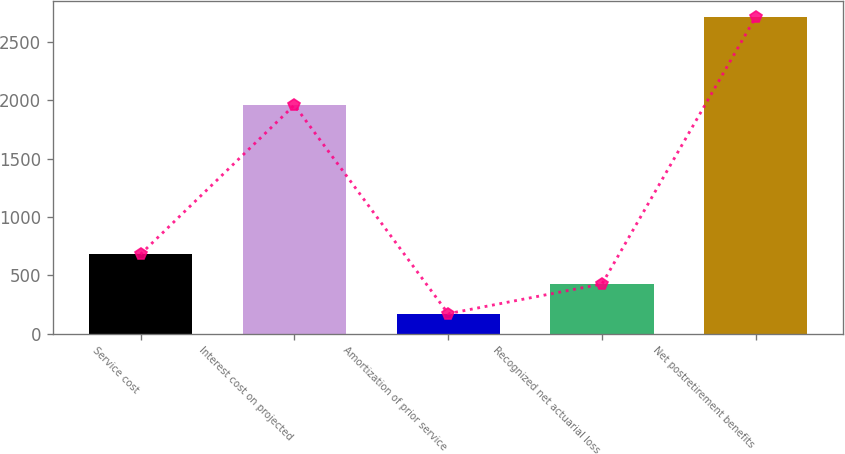<chart> <loc_0><loc_0><loc_500><loc_500><bar_chart><fcel>Service cost<fcel>Interest cost on projected<fcel>Amortization of prior service<fcel>Recognized net actuarial loss<fcel>Net postretirement benefits<nl><fcel>679.2<fcel>1958<fcel>170<fcel>424.6<fcel>2716<nl></chart> 